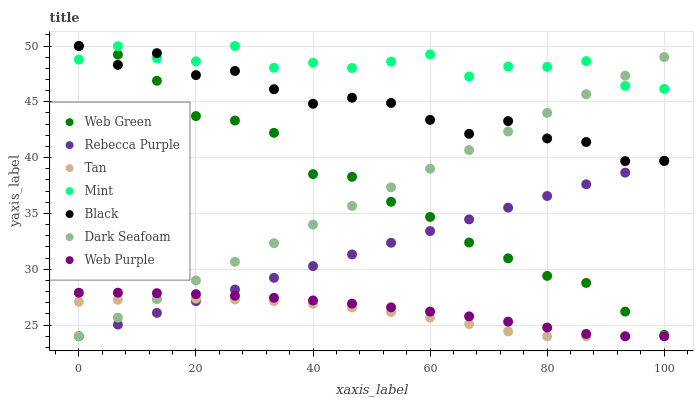Does Tan have the minimum area under the curve?
Answer yes or no. Yes. Does Mint have the maximum area under the curve?
Answer yes or no. Yes. Does Web Green have the minimum area under the curve?
Answer yes or no. No. Does Web Green have the maximum area under the curve?
Answer yes or no. No. Is Rebecca Purple the smoothest?
Answer yes or no. Yes. Is Mint the roughest?
Answer yes or no. Yes. Is Web Green the smoothest?
Answer yes or no. No. Is Web Green the roughest?
Answer yes or no. No. Does Web Purple have the lowest value?
Answer yes or no. Yes. Does Web Green have the lowest value?
Answer yes or no. No. Does Mint have the highest value?
Answer yes or no. Yes. Does Dark Seafoam have the highest value?
Answer yes or no. No. Is Web Purple less than Black?
Answer yes or no. Yes. Is Mint greater than Web Purple?
Answer yes or no. Yes. Does Web Green intersect Mint?
Answer yes or no. Yes. Is Web Green less than Mint?
Answer yes or no. No. Is Web Green greater than Mint?
Answer yes or no. No. Does Web Purple intersect Black?
Answer yes or no. No. 